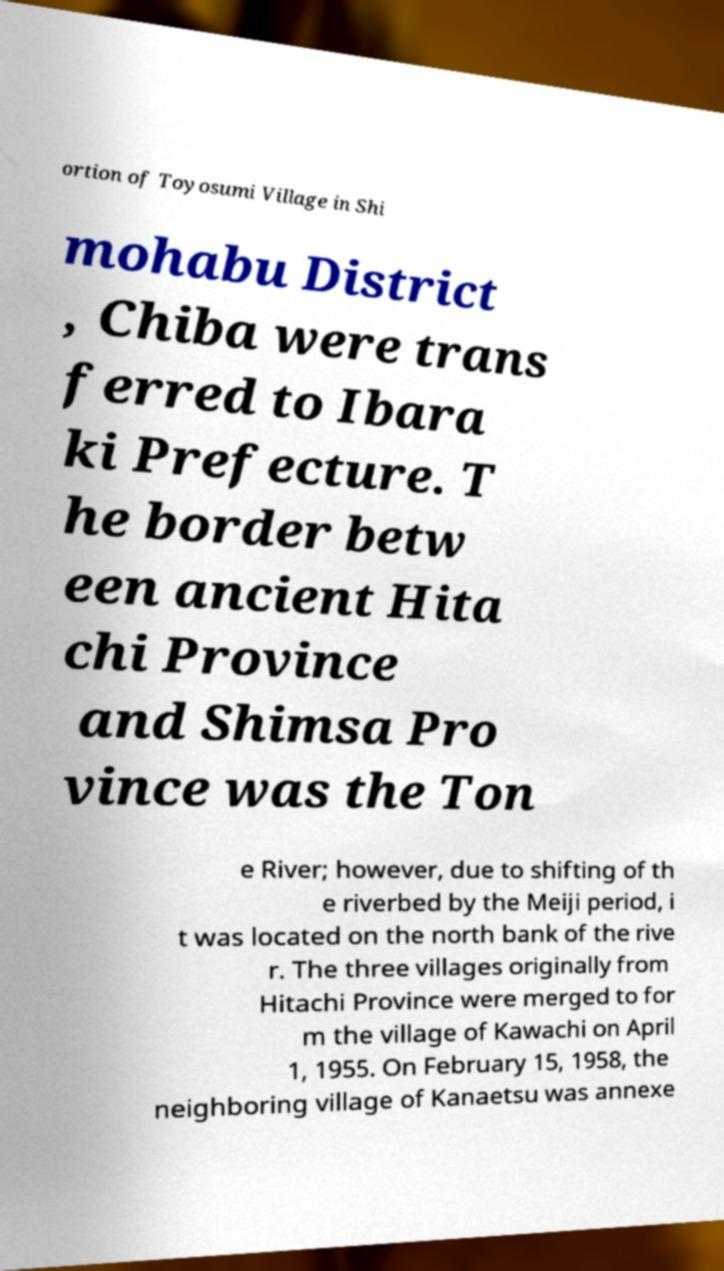I need the written content from this picture converted into text. Can you do that? ortion of Toyosumi Village in Shi mohabu District , Chiba were trans ferred to Ibara ki Prefecture. T he border betw een ancient Hita chi Province and Shimsa Pro vince was the Ton e River; however, due to shifting of th e riverbed by the Meiji period, i t was located on the north bank of the rive r. The three villages originally from Hitachi Province were merged to for m the village of Kawachi on April 1, 1955. On February 15, 1958, the neighboring village of Kanaetsu was annexe 